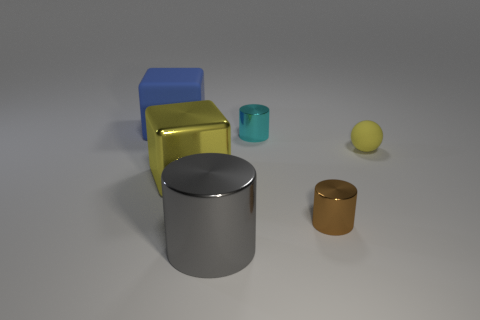Is the tiny matte sphere the same color as the large metallic cube?
Keep it short and to the point. Yes. There is a cylinder right of the cyan shiny cylinder; what is its material?
Give a very brief answer. Metal. Is the material of the small cylinder behind the tiny brown object the same as the tiny yellow object?
Keep it short and to the point. No. What number of objects are either brown rubber spheres or yellow balls that are to the right of the yellow metal thing?
Make the answer very short. 1. The cyan shiny thing that is the same shape as the small brown shiny thing is what size?
Make the answer very short. Small. Is there anything else that is the same size as the cyan cylinder?
Your answer should be compact. Yes. There is a yellow block; are there any large blue rubber things in front of it?
Your answer should be very brief. No. Is the color of the tiny cylinder in front of the yellow matte object the same as the tiny cylinder that is behind the yellow rubber ball?
Give a very brief answer. No. Are there any large yellow things of the same shape as the gray thing?
Your answer should be compact. No. What number of other objects are there of the same color as the large matte cube?
Offer a very short reply. 0. 